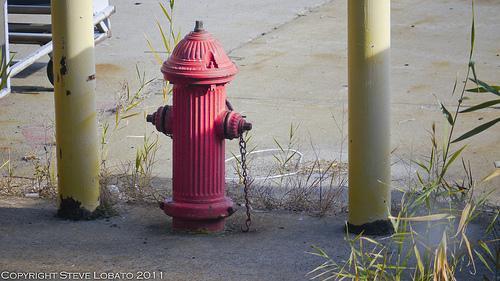How many poles are pictured?
Give a very brief answer. 2. 